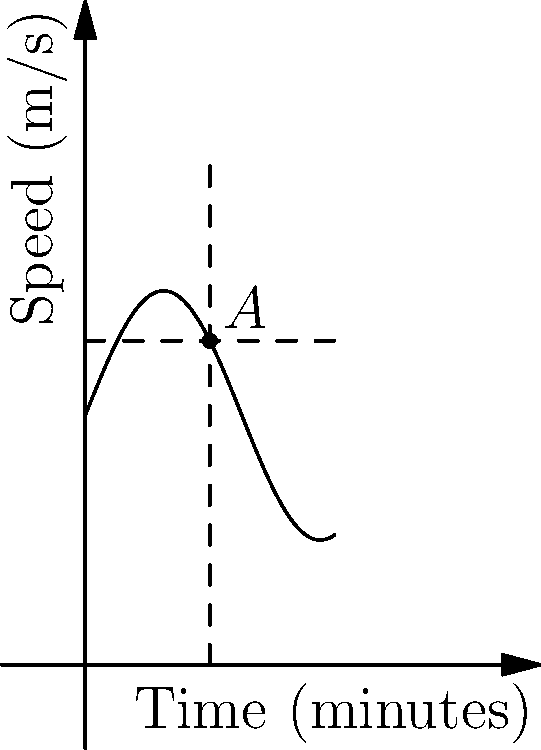The graph represents the speed of Wolverhampton Wanderers' star player during a crucial match against Arsenal in 1960. At point $A$, 5 minutes into the game, the player's speed is increasing. Calculate the instantaneous rate of change of the player's speed at this point. To find the instantaneous rate of change at point $A$, we need to calculate the derivative of the function at $x=5$. The function representing the player's speed is:

$$f(x) = 5\sin(\frac{x}{2}) + 10$$

1) First, let's find the derivative of this function:
   $$f'(x) = 5 \cdot \frac{1}{2} \cos(\frac{x}{2}) = \frac{5}{2} \cos(\frac{x}{2})$$

2) Now, we evaluate this derivative at $x=5$:
   $$f'(5) = \frac{5}{2} \cos(\frac{5}{2})$$

3) Using a calculator or trigonometric tables (as a historian might have done in 1960):
   $$\cos(\frac{5}{2}) \approx 0.7071$$

4) Therefore:
   $$f'(5) = \frac{5}{2} \cdot 0.7071 \approx 1.7678$$

This value represents the slope of the tangent line at point $A$, which is the instantaneous rate of change of the player's speed at that moment.
Answer: $1.7678$ m/s² 